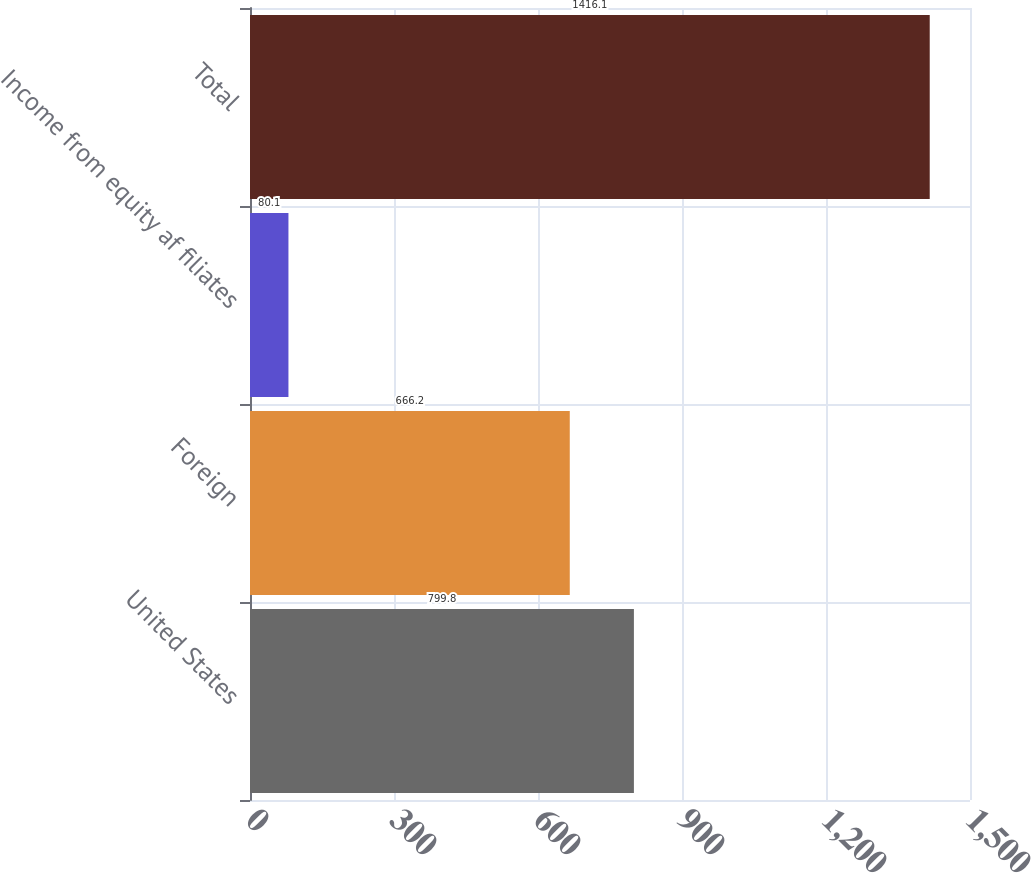Convert chart. <chart><loc_0><loc_0><loc_500><loc_500><bar_chart><fcel>United States<fcel>Foreign<fcel>Income from equity af filiates<fcel>Total<nl><fcel>799.8<fcel>666.2<fcel>80.1<fcel>1416.1<nl></chart> 